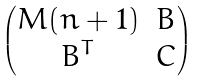<formula> <loc_0><loc_0><loc_500><loc_500>\begin{pmatrix} M ( n + 1 ) & B \\ B ^ { T } & C \end{pmatrix}</formula> 